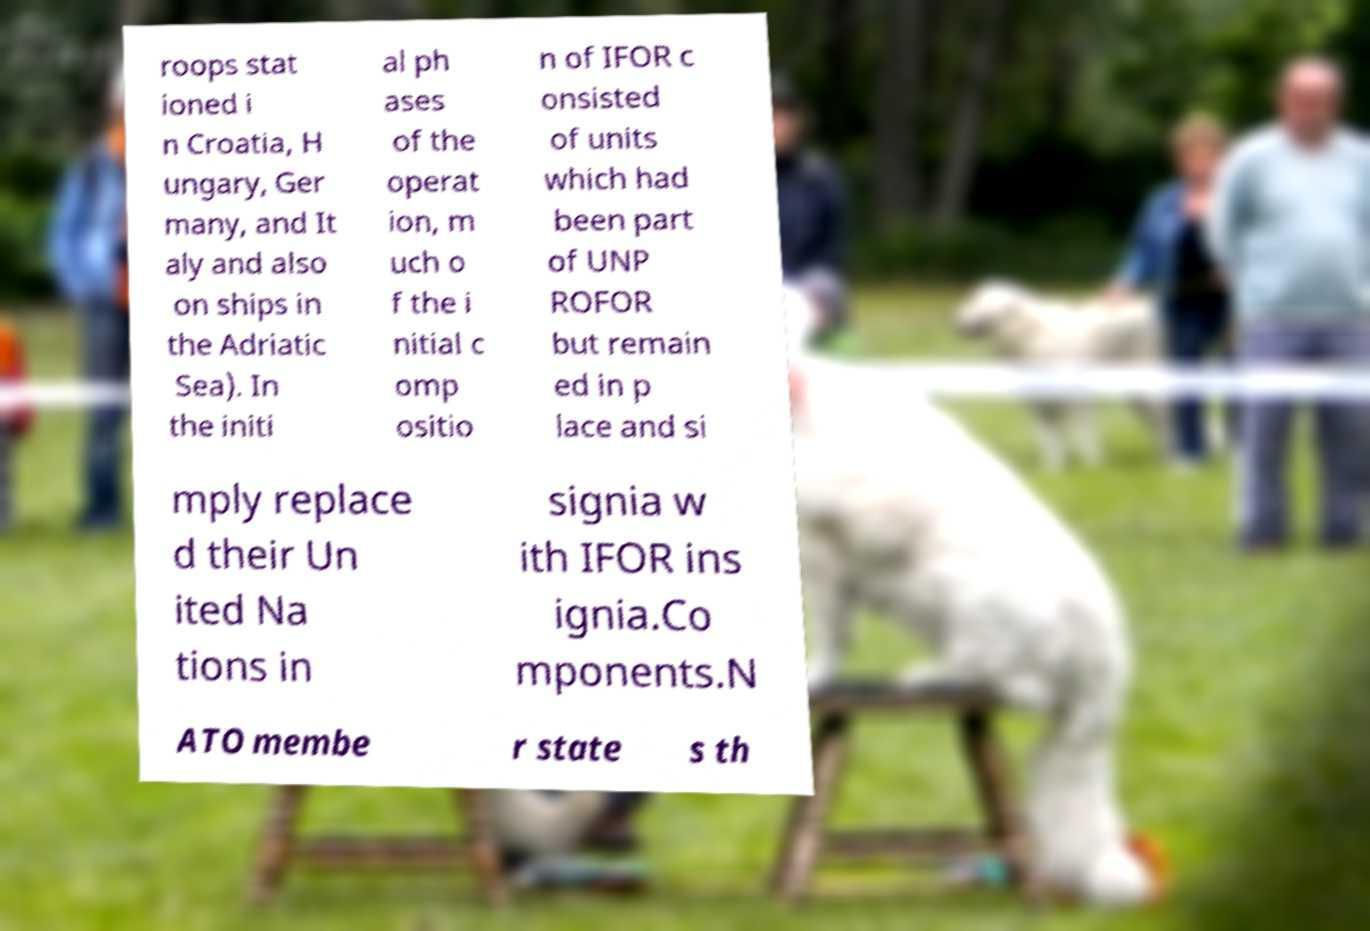Please read and relay the text visible in this image. What does it say? roops stat ioned i n Croatia, H ungary, Ger many, and It aly and also on ships in the Adriatic Sea). In the initi al ph ases of the operat ion, m uch o f the i nitial c omp ositio n of IFOR c onsisted of units which had been part of UNP ROFOR but remain ed in p lace and si mply replace d their Un ited Na tions in signia w ith IFOR ins ignia.Co mponents.N ATO membe r state s th 